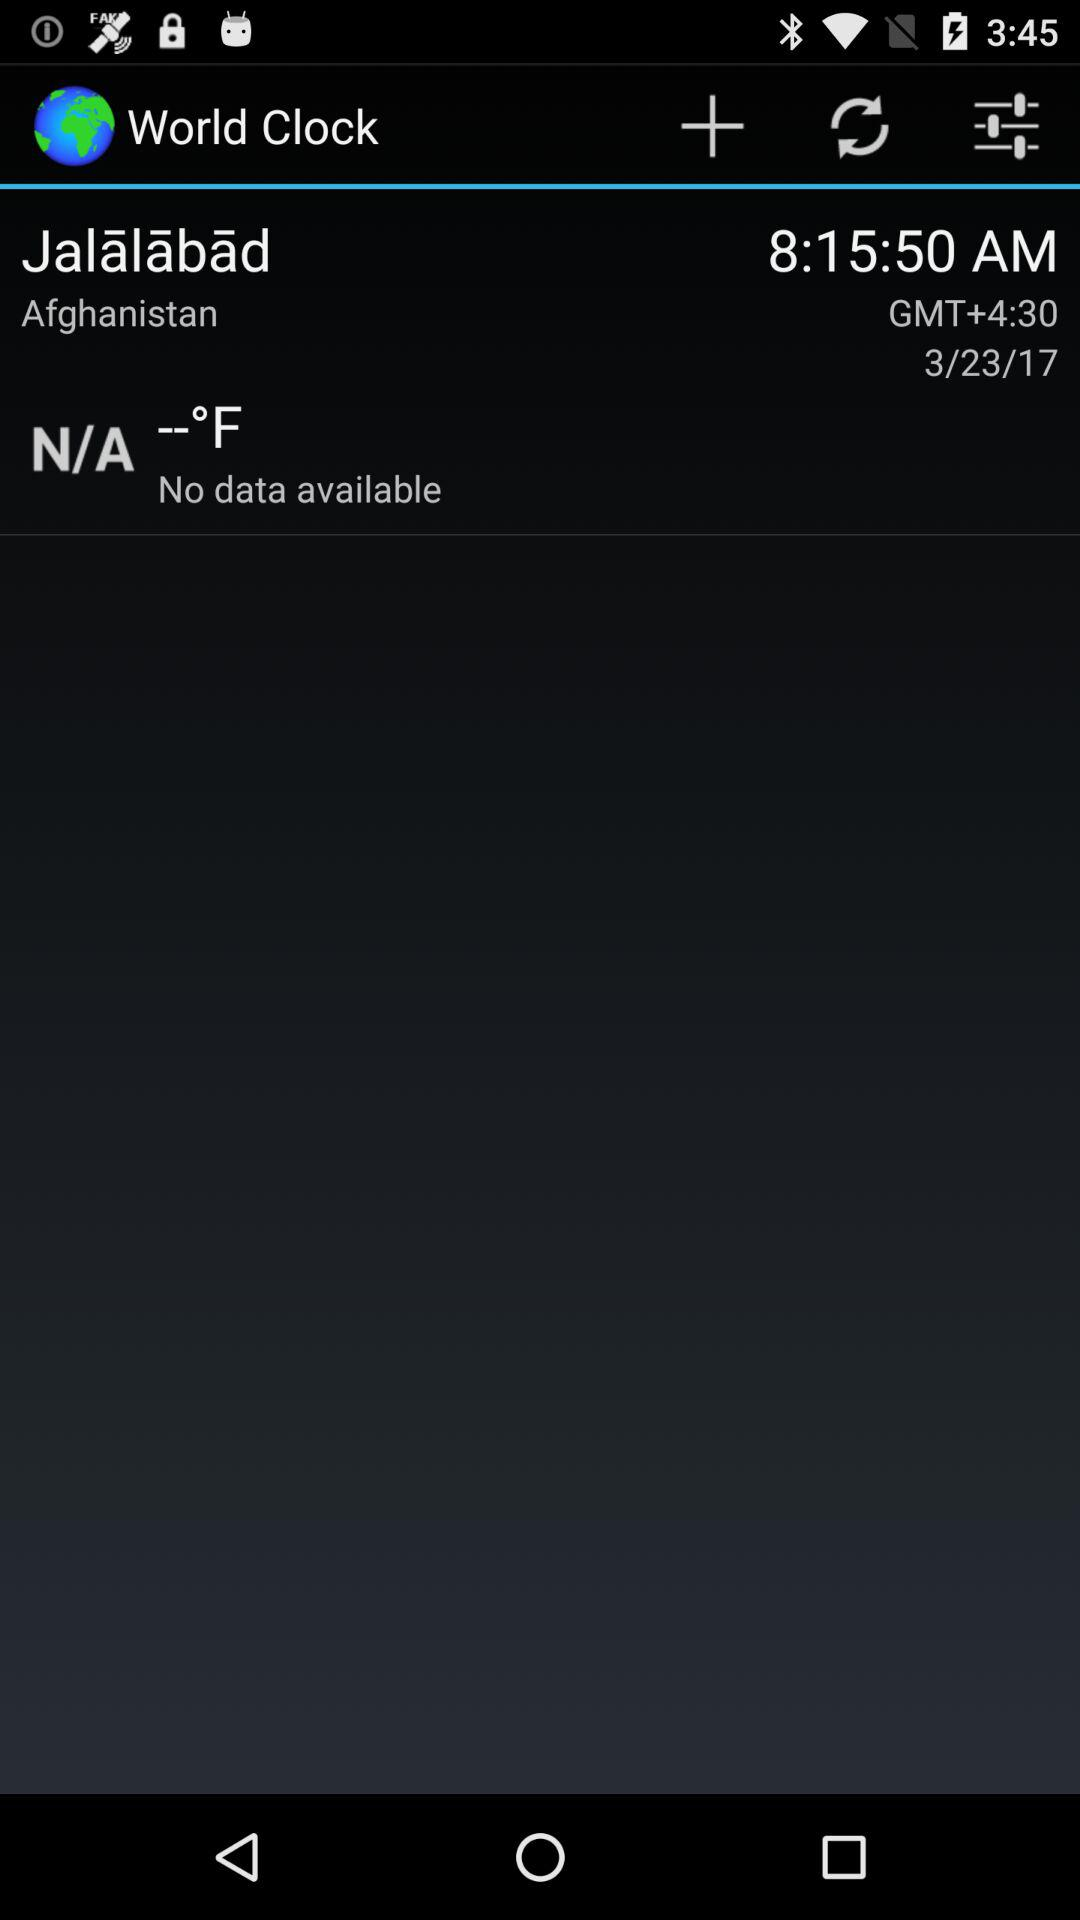Is there any data available? There is no data available. 